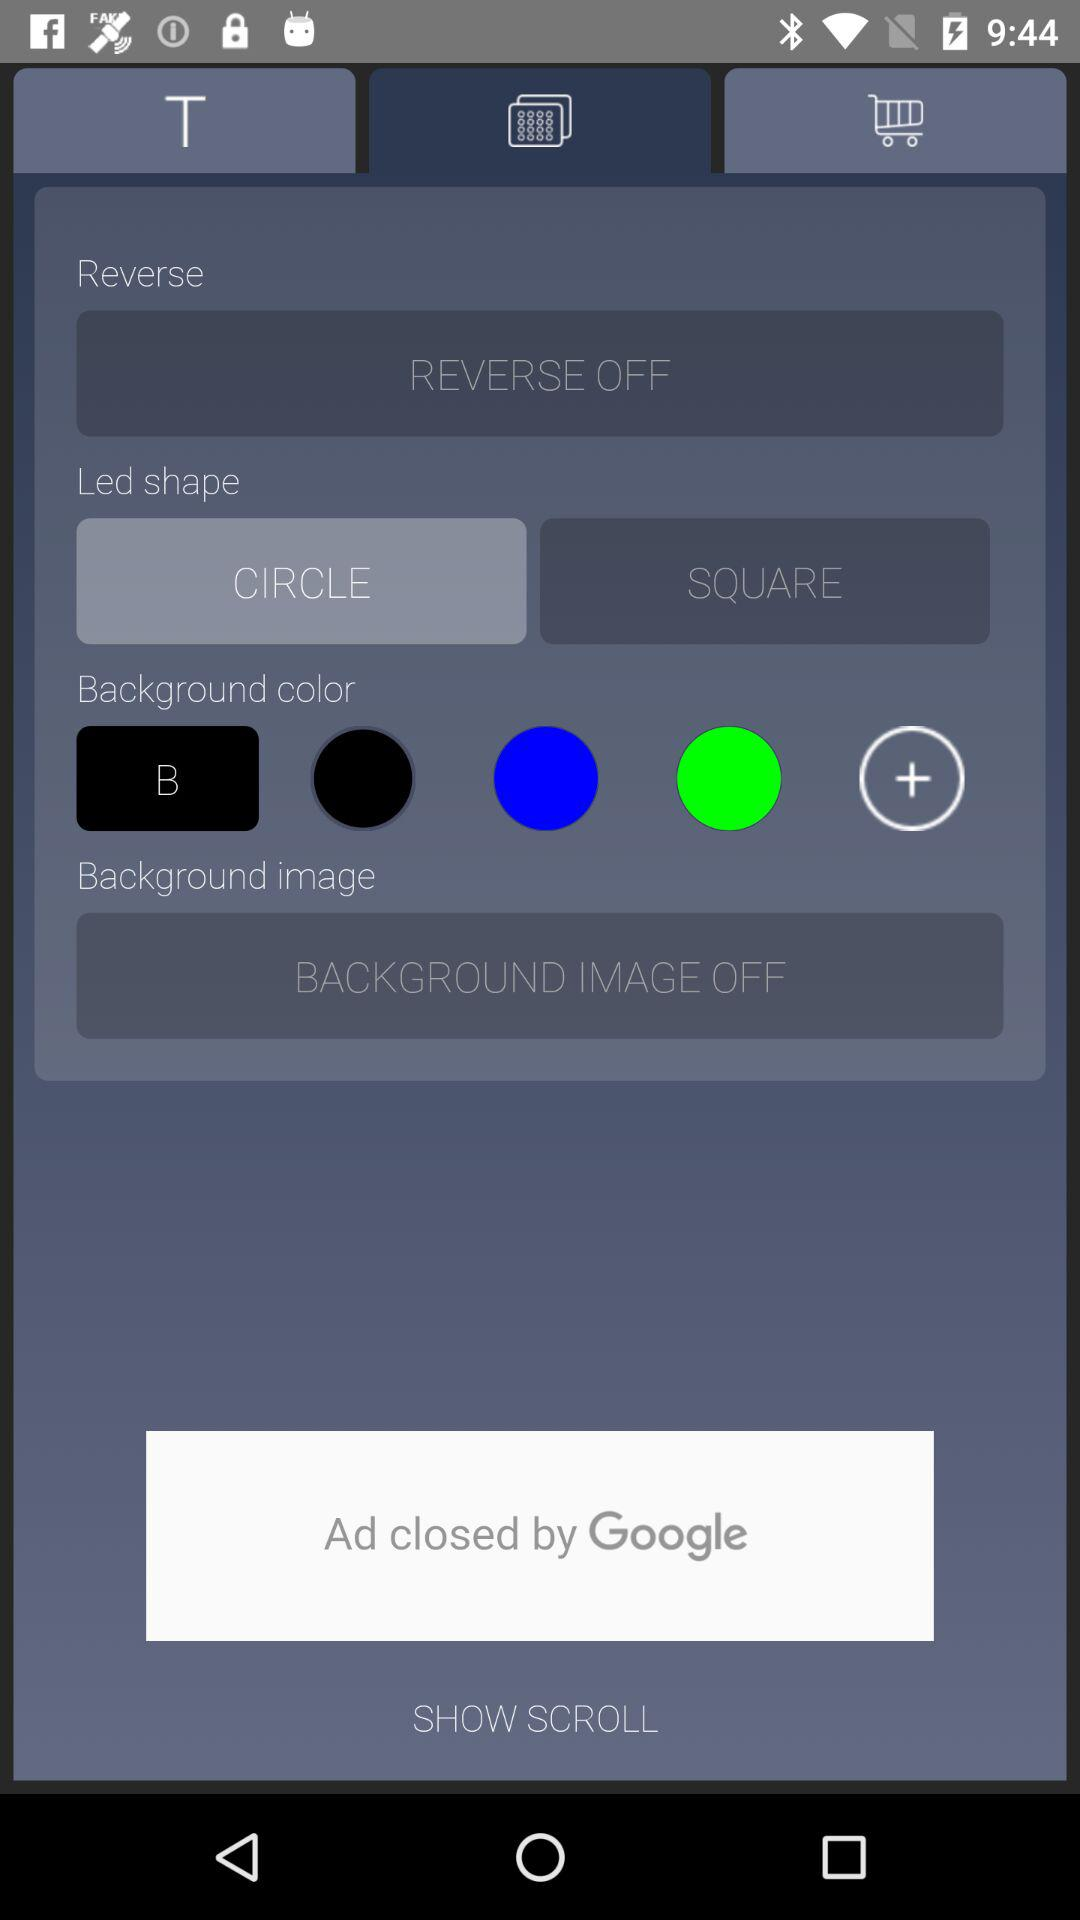What's the background image mode? The background image mode is off. 